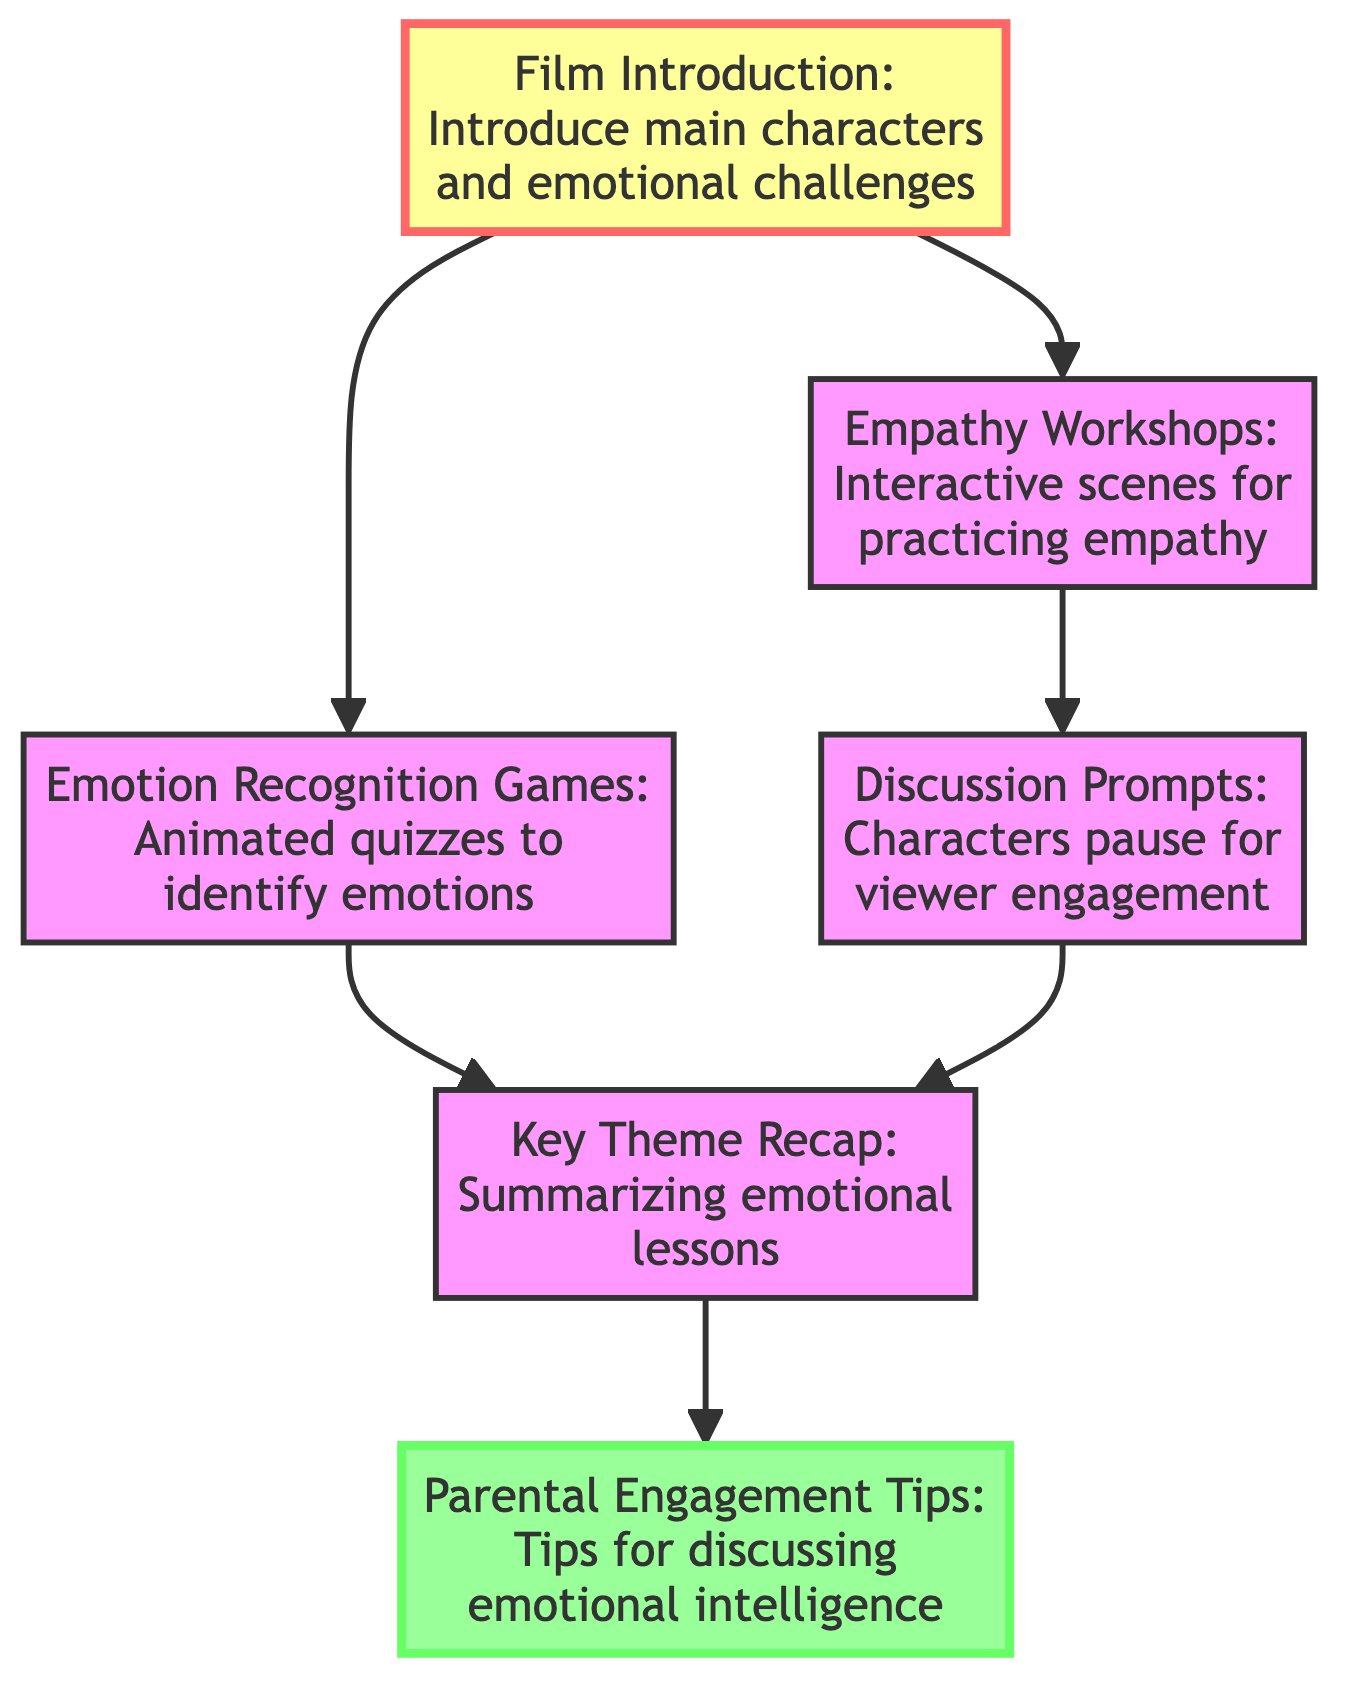What is the starting point of the flow in the diagram? The flowchart begins from the "Film Introduction" node, which serves as the initial step in the audience engagement strategies.
Answer: Film Introduction How many nodes are present in the diagram? To find the number of nodes, we can count each unique element in the "nodes" section. There are 6 distinct nodes listed.
Answer: 6 Which node connects to both "Empathy Workshops" and "Emotion Recognition Games"? The "Film Introduction" node has directed edges leading to both "Empathy Workshops" and "Emotion Recognition Games," making it the connecting point between them.
Answer: Film Introduction What is the last step in the engagement strategy flow? The last node in the series is "Parental Engagement Tips," as it is the final element connected after the "Key Theme Recap."
Answer: Parental Engagement Tips Do "Discussion Prompts" lead to "Emotion Recognition Games"? No, the "Discussion Prompts" node does not point to "Emotion Recognition Games"; it goes to "Key Theme Recap" instead.
Answer: No What is the relationship between "Empathy Workshops" and "Discussion Prompts"? There is a directed edge from "Empathy Workshops" to "Discussion Prompts," indicating that after engaging in workshops, the story continues to prompts for discussion.
Answer: Empathy Workshops → Discussion Prompts How many edges are in the diagram? By counting the directed connections listed in the "edges" section, we determine there are 6 edges establishing relationships between the nodes.
Answer: 6 Which nodes summarize emotional lessons? The "Key Theme Recap" node is responsible for summarizing emotional lessons at the end of the key scenes in the film.
Answer: Key Theme Recap What is the purpose of the "Parental Engagement Tips" node? The "Parental Engagement Tips" node provides advice to parents on discussing emotional intelligence, making it a supportive resource following the main story.
Answer: Tips on discussing emotional intelligence 